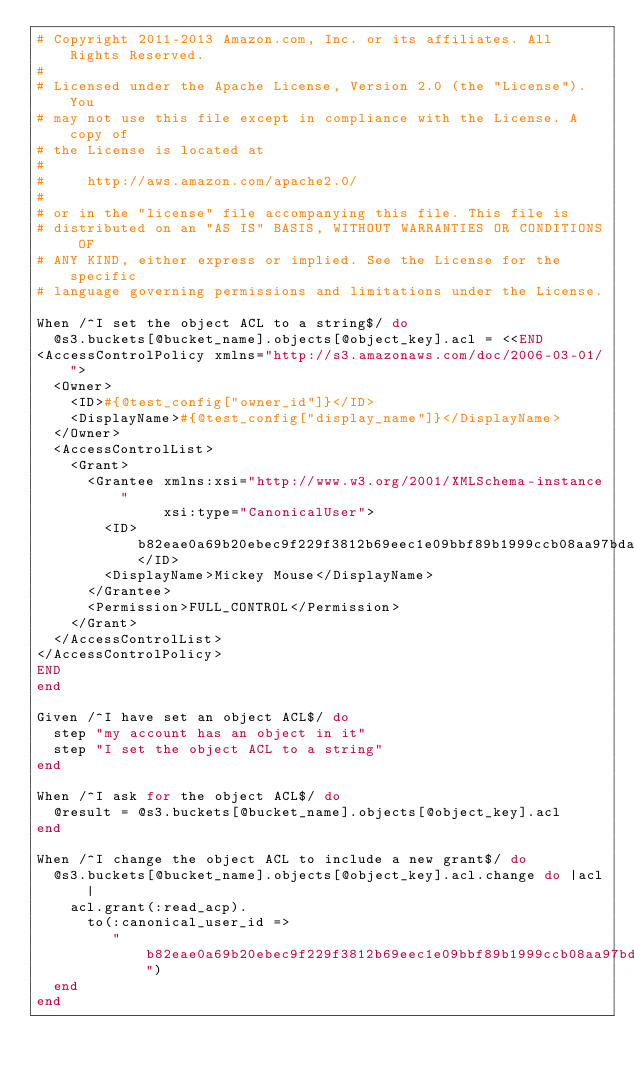Convert code to text. <code><loc_0><loc_0><loc_500><loc_500><_Ruby_># Copyright 2011-2013 Amazon.com, Inc. or its affiliates. All Rights Reserved.
#
# Licensed under the Apache License, Version 2.0 (the "License"). You
# may not use this file except in compliance with the License. A copy of
# the License is located at
#
#     http://aws.amazon.com/apache2.0/
#
# or in the "license" file accompanying this file. This file is
# distributed on an "AS IS" BASIS, WITHOUT WARRANTIES OR CONDITIONS OF
# ANY KIND, either express or implied. See the License for the specific
# language governing permissions and limitations under the License.

When /^I set the object ACL to a string$/ do
  @s3.buckets[@bucket_name].objects[@object_key].acl = <<END
<AccessControlPolicy xmlns="http://s3.amazonaws.com/doc/2006-03-01/">
  <Owner>
    <ID>#{@test_config["owner_id"]}</ID>
    <DisplayName>#{@test_config["display_name"]}</DisplayName>
  </Owner>
  <AccessControlList>
    <Grant>
      <Grantee xmlns:xsi="http://www.w3.org/2001/XMLSchema-instance"
               xsi:type="CanonicalUser">
        <ID>b82eae0a69b20ebec9f229f3812b69eec1e09bbf89b1999ccb08aa97bda77270</ID>
        <DisplayName>Mickey Mouse</DisplayName>
      </Grantee>
      <Permission>FULL_CONTROL</Permission>
    </Grant>
  </AccessControlList>
</AccessControlPolicy>
END
end

Given /^I have set an object ACL$/ do
  step "my account has an object in it"
  step "I set the object ACL to a string"
end

When /^I ask for the object ACL$/ do
  @result = @s3.buckets[@bucket_name].objects[@object_key].acl
end

When /^I change the object ACL to include a new grant$/ do
  @s3.buckets[@bucket_name].objects[@object_key].acl.change do |acl|
    acl.grant(:read_acp).
      to(:canonical_user_id =>
         "b82eae0a69b20ebec9f229f3812b69eec1e09bbf89b1999ccb08aa97bda77270")
  end
end
</code> 